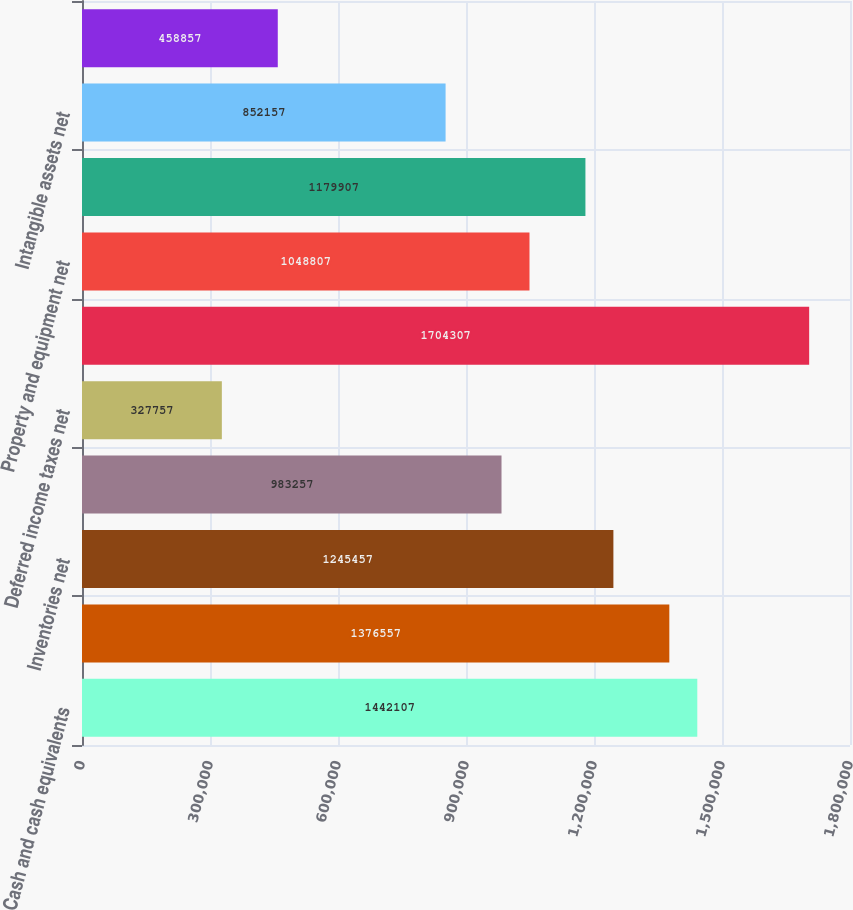<chart> <loc_0><loc_0><loc_500><loc_500><bar_chart><fcel>Cash and cash equivalents<fcel>Accounts receivable net<fcel>Inventories net<fcel>Prepaid expenses and other<fcel>Deferred income taxes net<fcel>Total current assets<fcel>Property and equipment net<fcel>Goodwill<fcel>Intangible assets net<fcel>Other assets<nl><fcel>1.44211e+06<fcel>1.37656e+06<fcel>1.24546e+06<fcel>983257<fcel>327757<fcel>1.70431e+06<fcel>1.04881e+06<fcel>1.17991e+06<fcel>852157<fcel>458857<nl></chart> 